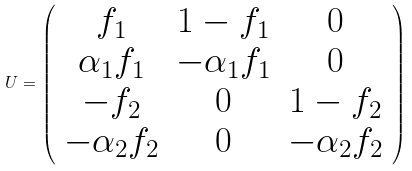<formula> <loc_0><loc_0><loc_500><loc_500>U = \left ( \begin{array} { c c c } f _ { 1 } & 1 - f _ { 1 } & 0 \\ \alpha _ { 1 } f _ { 1 } & - \alpha _ { 1 } f _ { 1 } & 0 \\ - f _ { 2 } & 0 & 1 - f _ { 2 } \\ - \alpha _ { 2 } f _ { 2 } & 0 & - \alpha _ { 2 } f _ { 2 } \end{array} \right )</formula> 